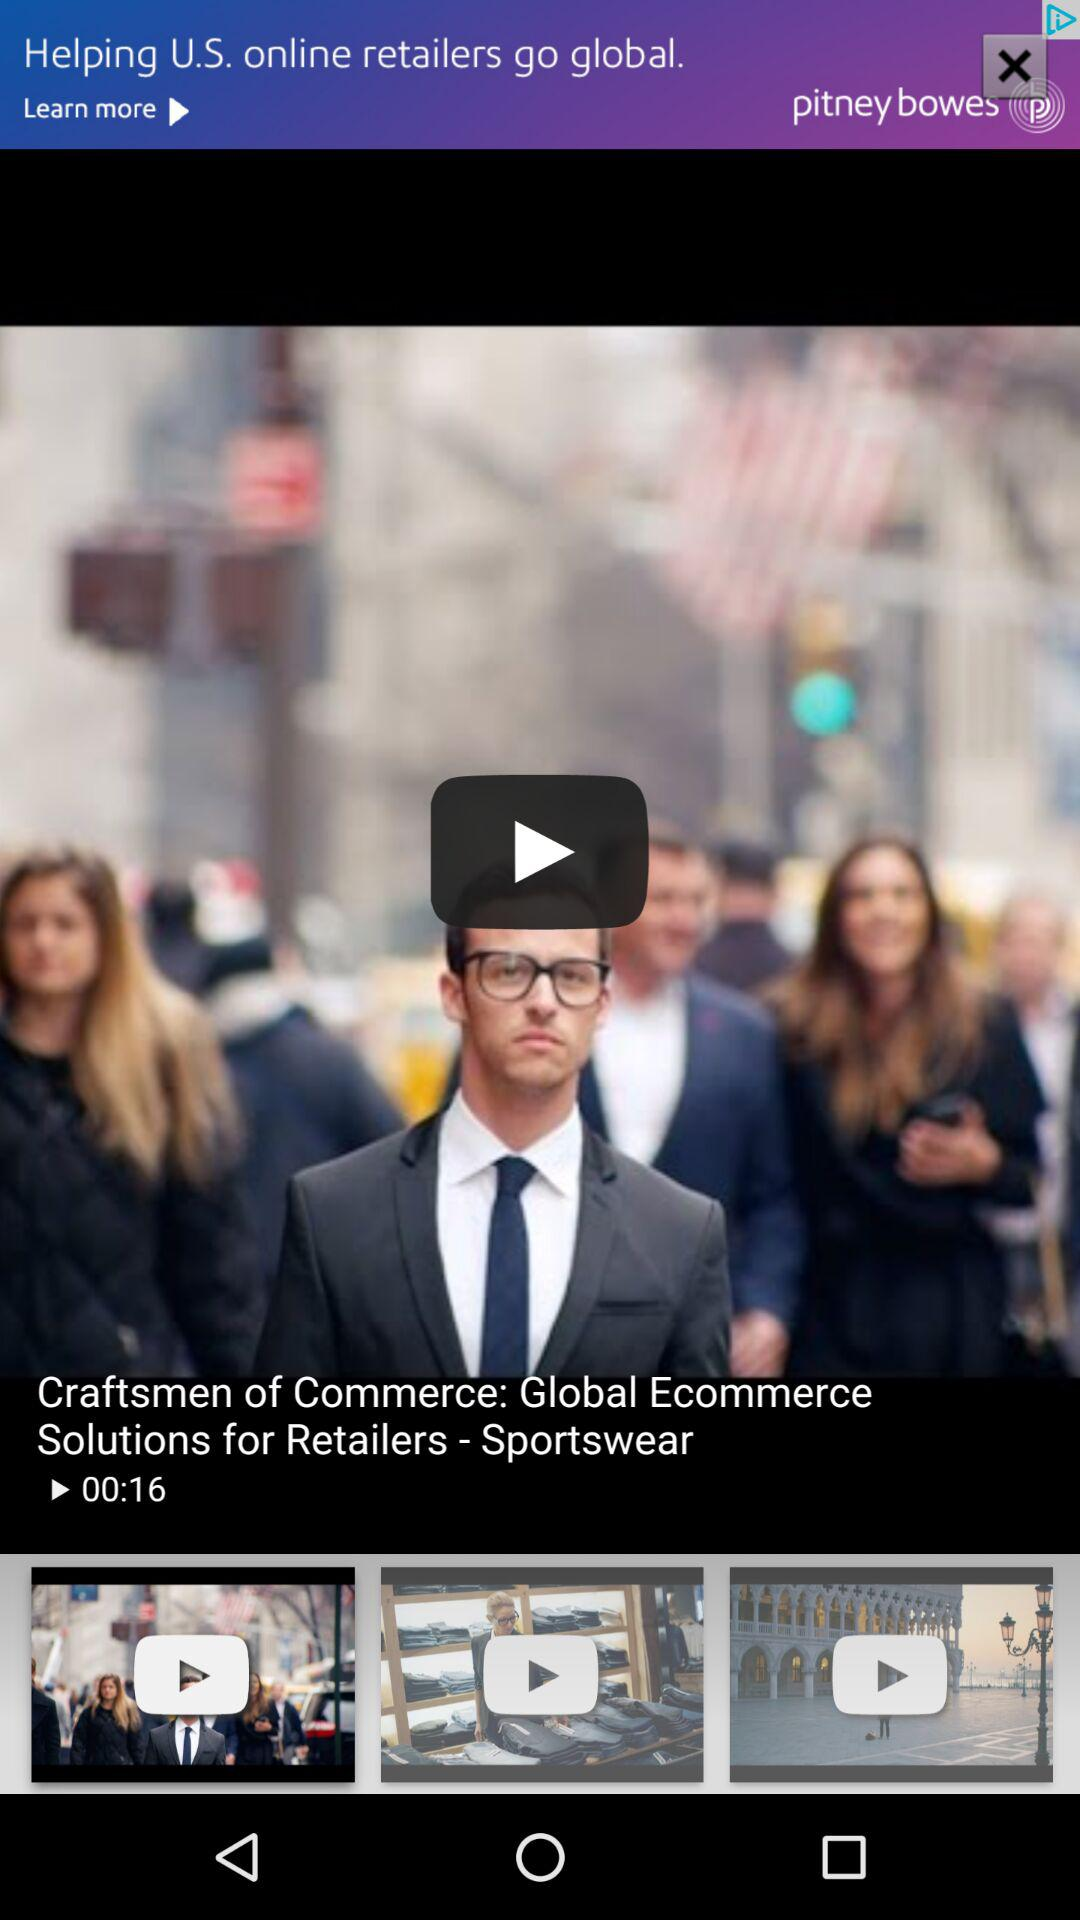What is the video's title? The video's title is "Craftsmen of Commerce: Global Ecommerce Solutions for Retailers - Sportswear". 